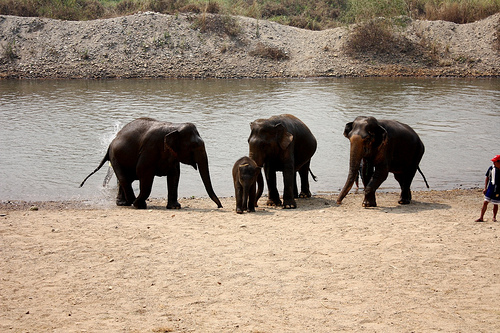<image>
Can you confirm if the calf is under the elephant? No. The calf is not positioned under the elephant. The vertical relationship between these objects is different. Is the elephant in front of the water? Yes. The elephant is positioned in front of the water, appearing closer to the camera viewpoint. 